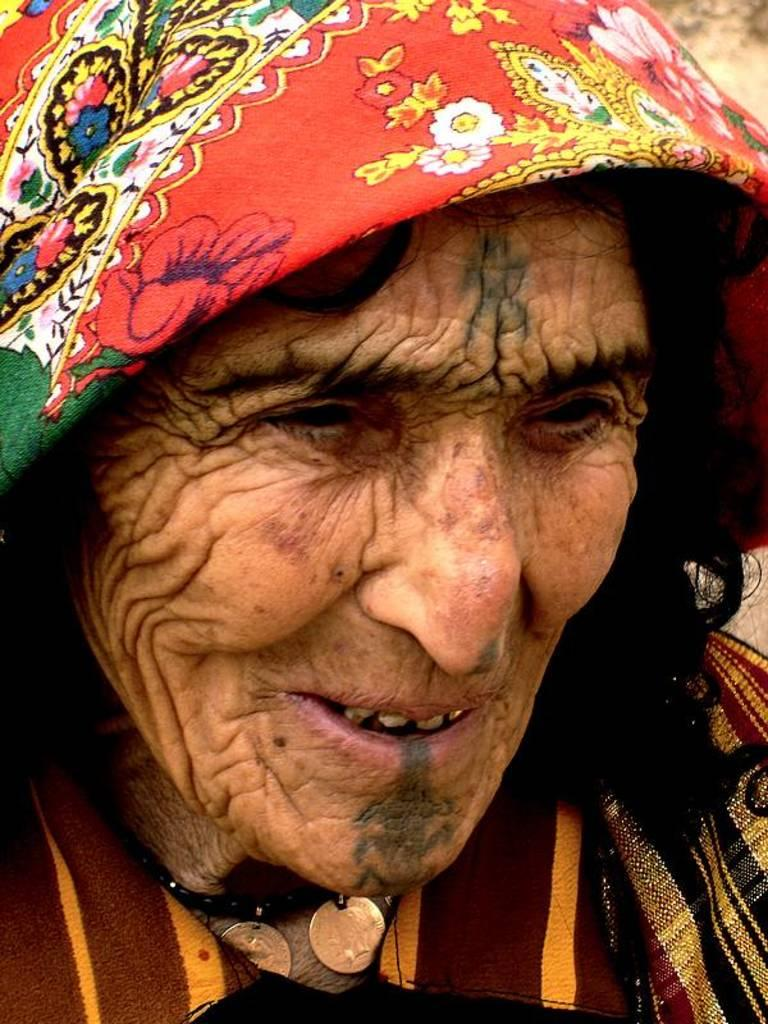Who is the main subject in the image? There is an old lady in the image. What is the old lady wearing? The old lady is wearing clothes. Are there any accessories visible on the old lady? Yes, the old lady is wearing a neck chain. What type of knowledge can be seen on the old lady's tongue in the image? There is no indication of knowledge or a tongue in the image; it only shows the old lady wearing clothes and a neck chain. 